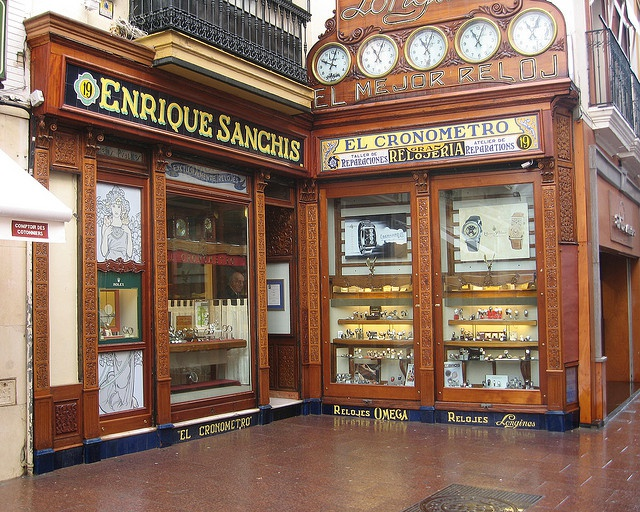Describe the objects in this image and their specific colors. I can see clock in beige, white, darkgray, khaki, and tan tones, clock in beige, white, darkgray, khaki, and tan tones, clock in beige, white, darkgray, khaki, and tan tones, clock in beige, white, and darkgray tones, and clock in beige, lightgray, darkgray, gray, and olive tones in this image. 